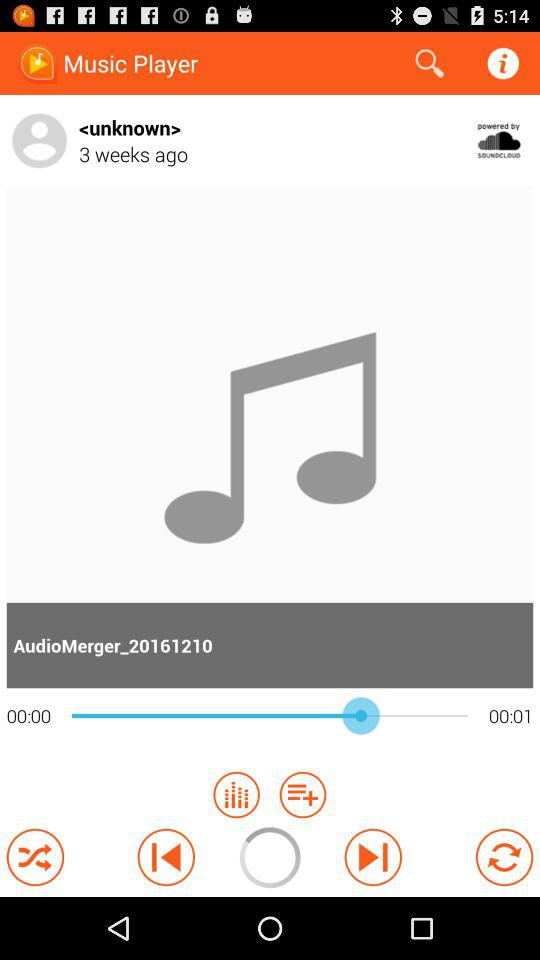How long ago was the music? The music was from 3 weeks ago. 